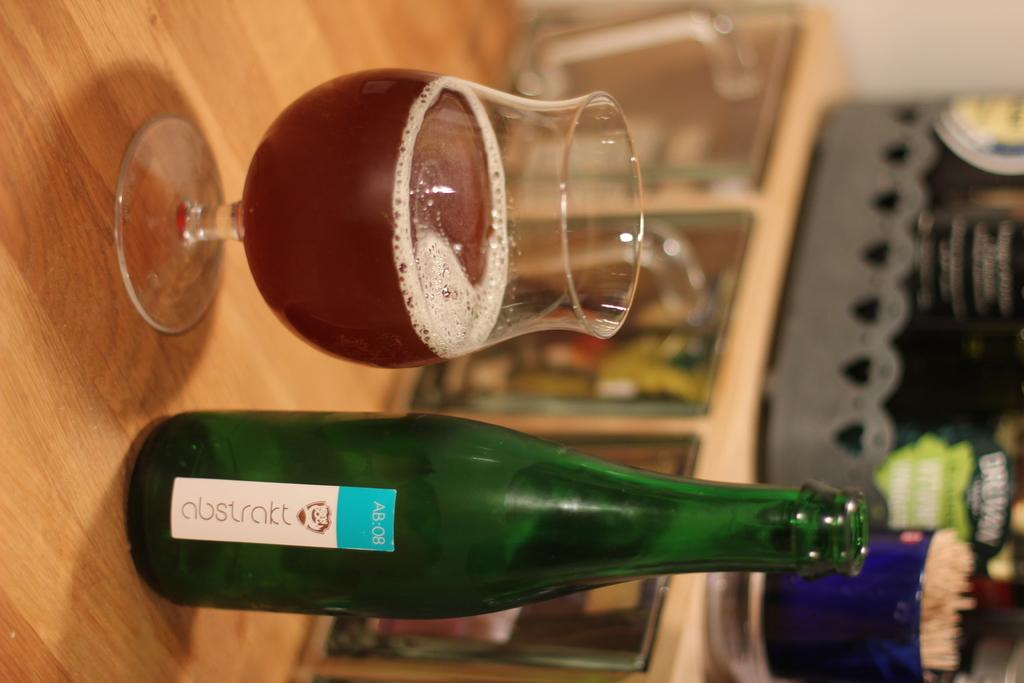<image>
Provide a brief description of the given image. A cup filled with liquor from a bottle of Abstrakt sitting on a table. 